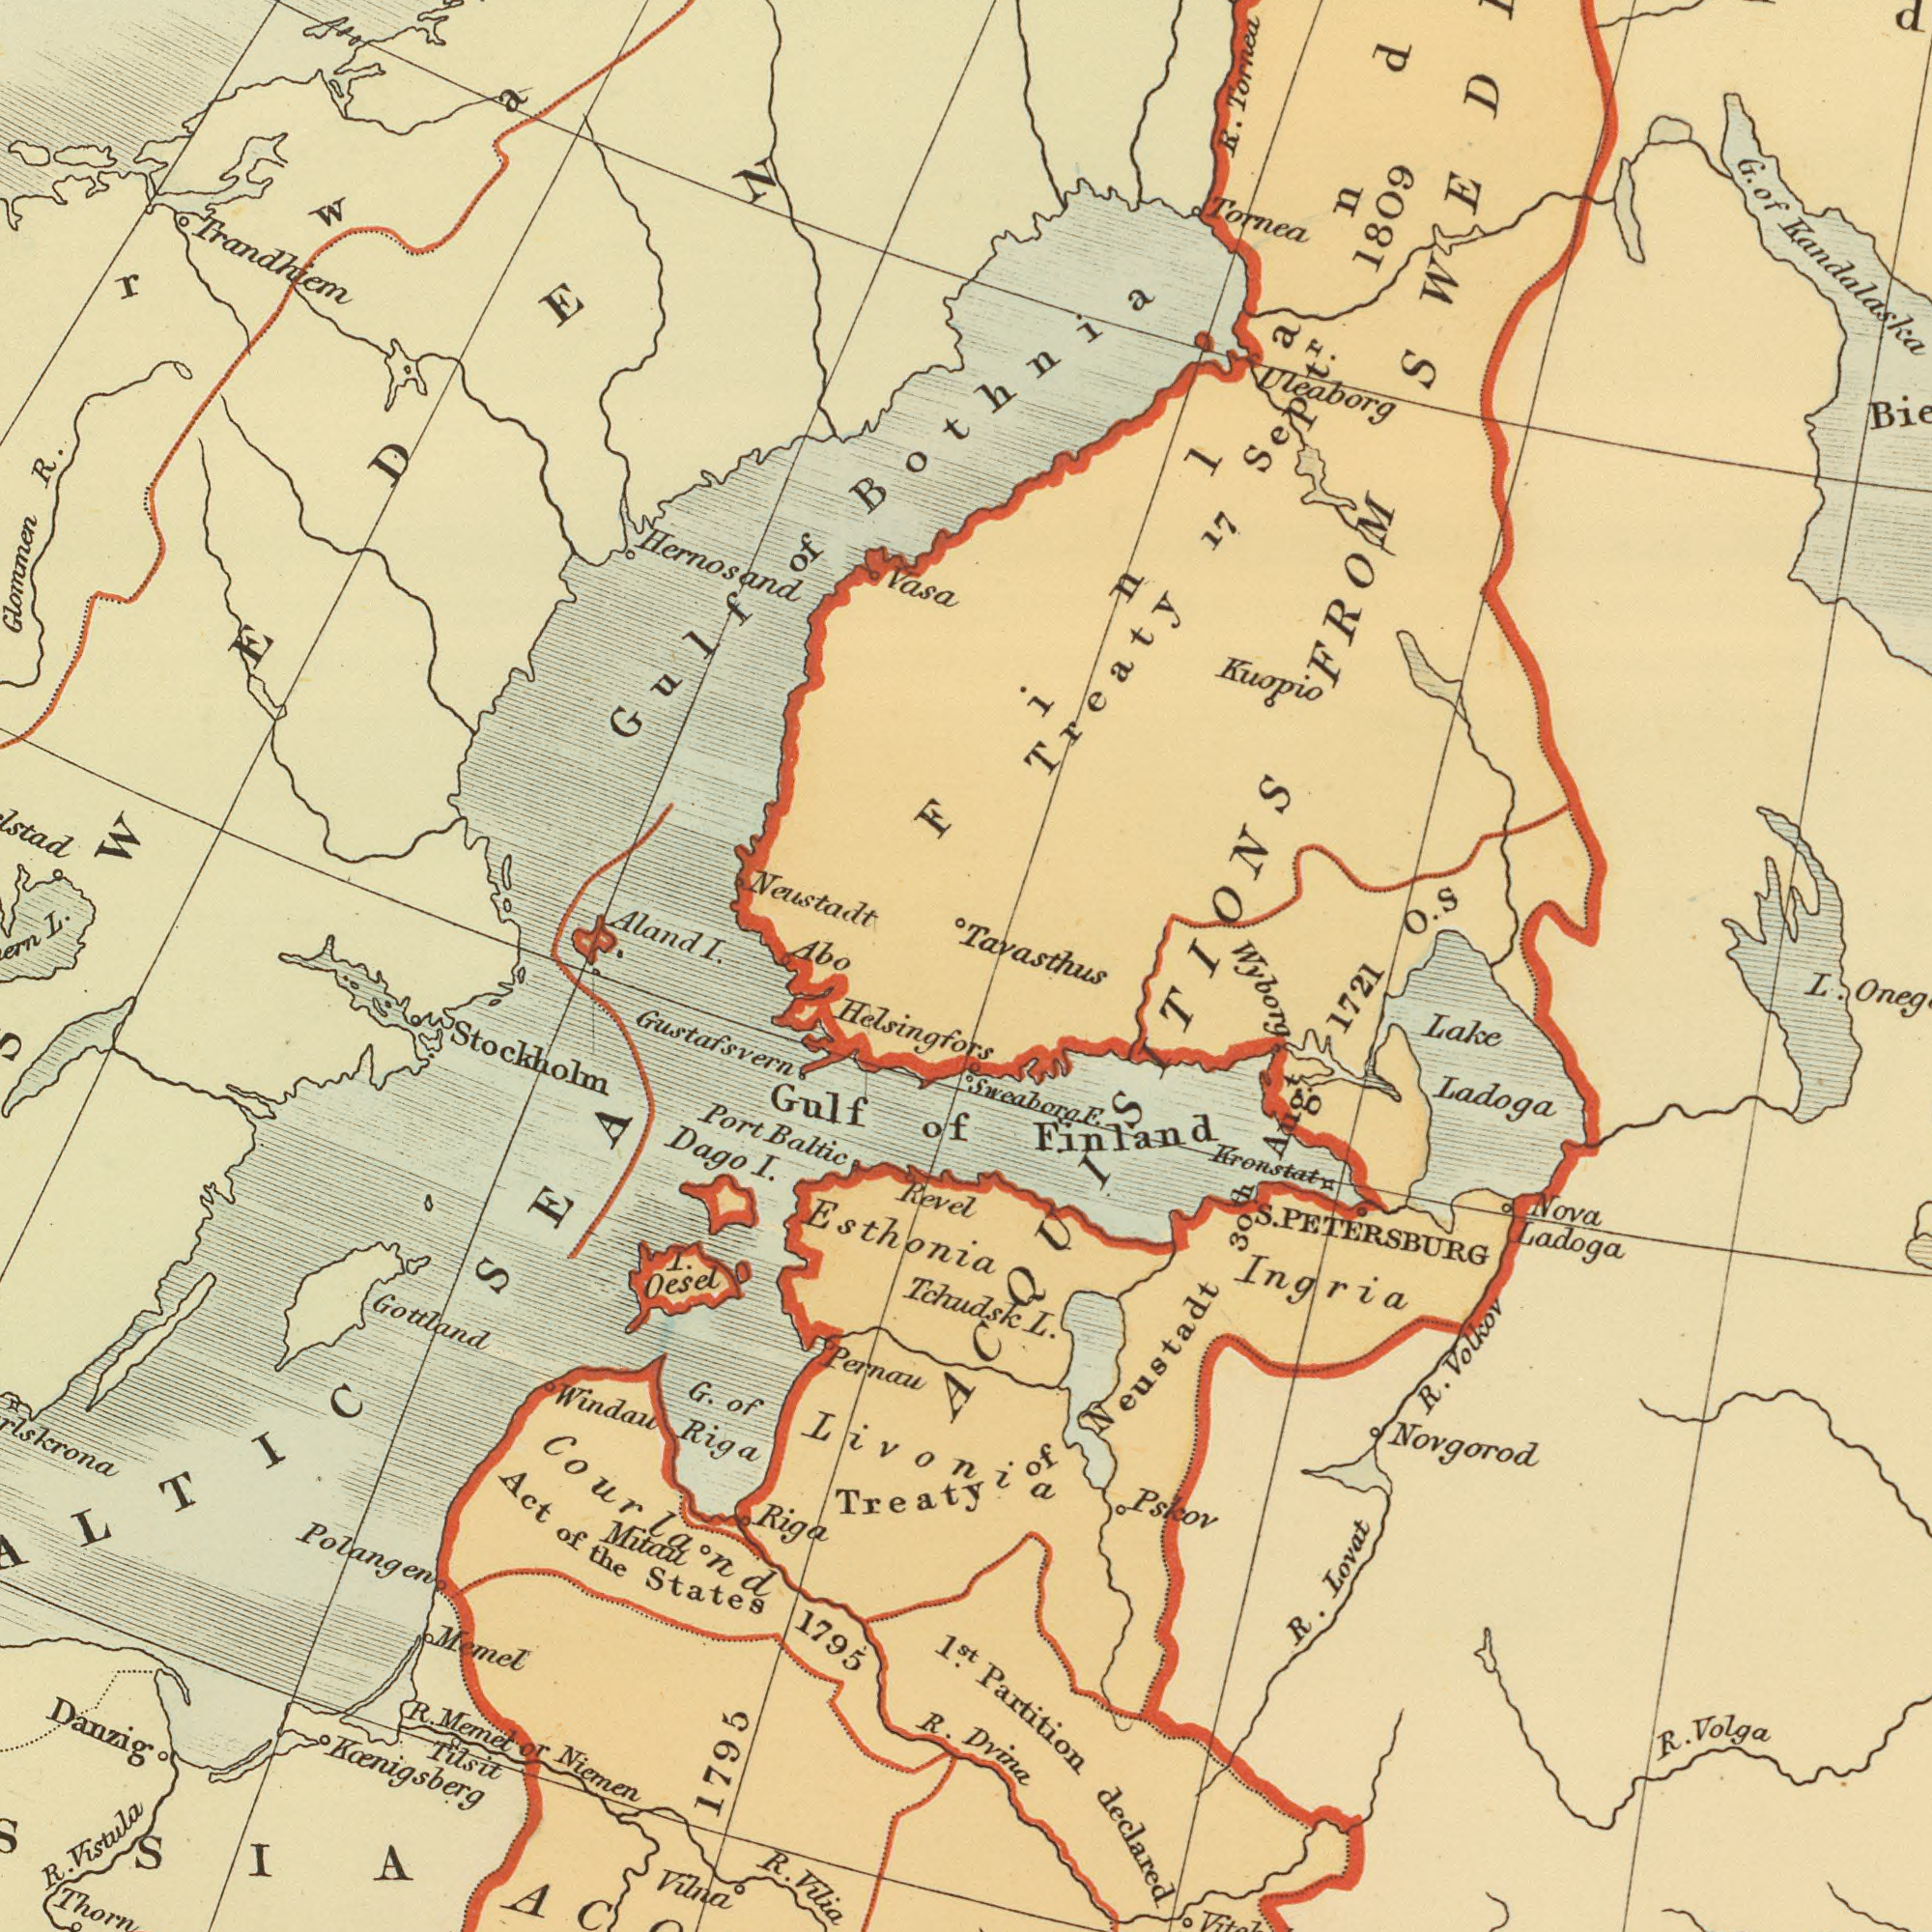What text is shown in the top-left quadrant? Neustadt Trandhiem Hernosand Aland R. I. L. Glommen Abo of Gulf Vasa SWEDEN ###rwa### What text is visible in the lower-left corner? Helsingfors Stockholm Gustafsvern Gottland Oesel Danzig Windau Polangen Vilna R. States 1795 Baltic Memel Gulf Revel I. Pernau Treaty Riga Vistula Act Dago Port R. Memet I. Mitail Tilsit Riga Esthonia Vilia Koenigsberg Tchudsk 1<sup>st</sup>. Livonia of of R. Niemen R. the 1795 G. or of SEA Courland SSIA What text is shown in the top-right quadrant? G. 17 Tavasthus O. Treaty R. Tornea Uleaborg 1809 Kuopio Bothnia FROM Kandalaska Tornea of Finland Sept<sup>r</sup>. S What text appears in the bottom-right area of the image? Partition declared Ladoga Novgorod Ingria Lovat R. L. Dvina Nova Kronstat Neustadt Lake R. Sweaborg Pskov Volkov Ladoga Volga E Aug. Finland 1721 PETERSBURG 30th R. of L. Wyborg ACQUISITIONS S. 